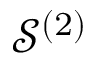Convert formula to latex. <formula><loc_0><loc_0><loc_500><loc_500>\mathcal { S } ^ { ( 2 ) }</formula> 